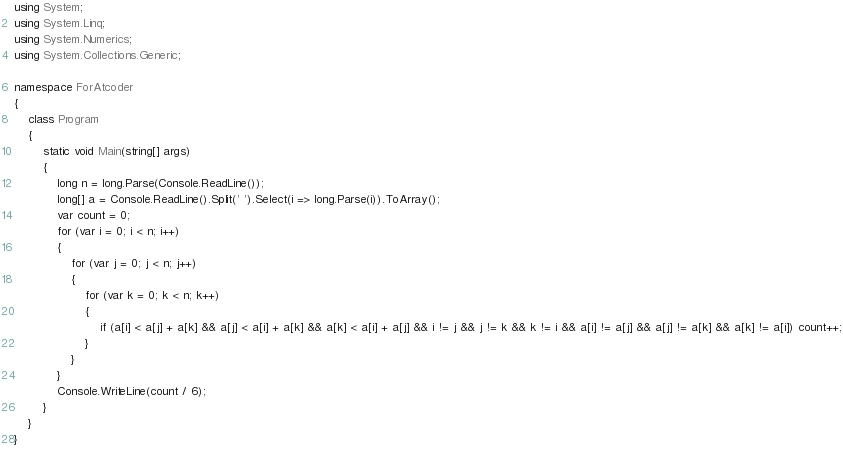<code> <loc_0><loc_0><loc_500><loc_500><_C#_>using System;
using System.Linq;
using System.Numerics;
using System.Collections.Generic;

namespace ForAtcoder
{
    class Program
    {
        static void Main(string[] args)
        {
            long n = long.Parse(Console.ReadLine());
            long[] a = Console.ReadLine().Split(' ').Select(i => long.Parse(i)).ToArray();
            var count = 0;
            for (var i = 0; i < n; i++)
            {
                for (var j = 0; j < n; j++)
                {
                    for (var k = 0; k < n; k++)
                    {
                        if (a[i] < a[j] + a[k] && a[j] < a[i] + a[k] && a[k] < a[i] + a[j] && i != j && j != k && k != i && a[i] != a[j] && a[j] != a[k] && a[k] != a[i]) count++;
                    }
                }
            }
            Console.WriteLine(count / 6);
        }
    }
}</code> 